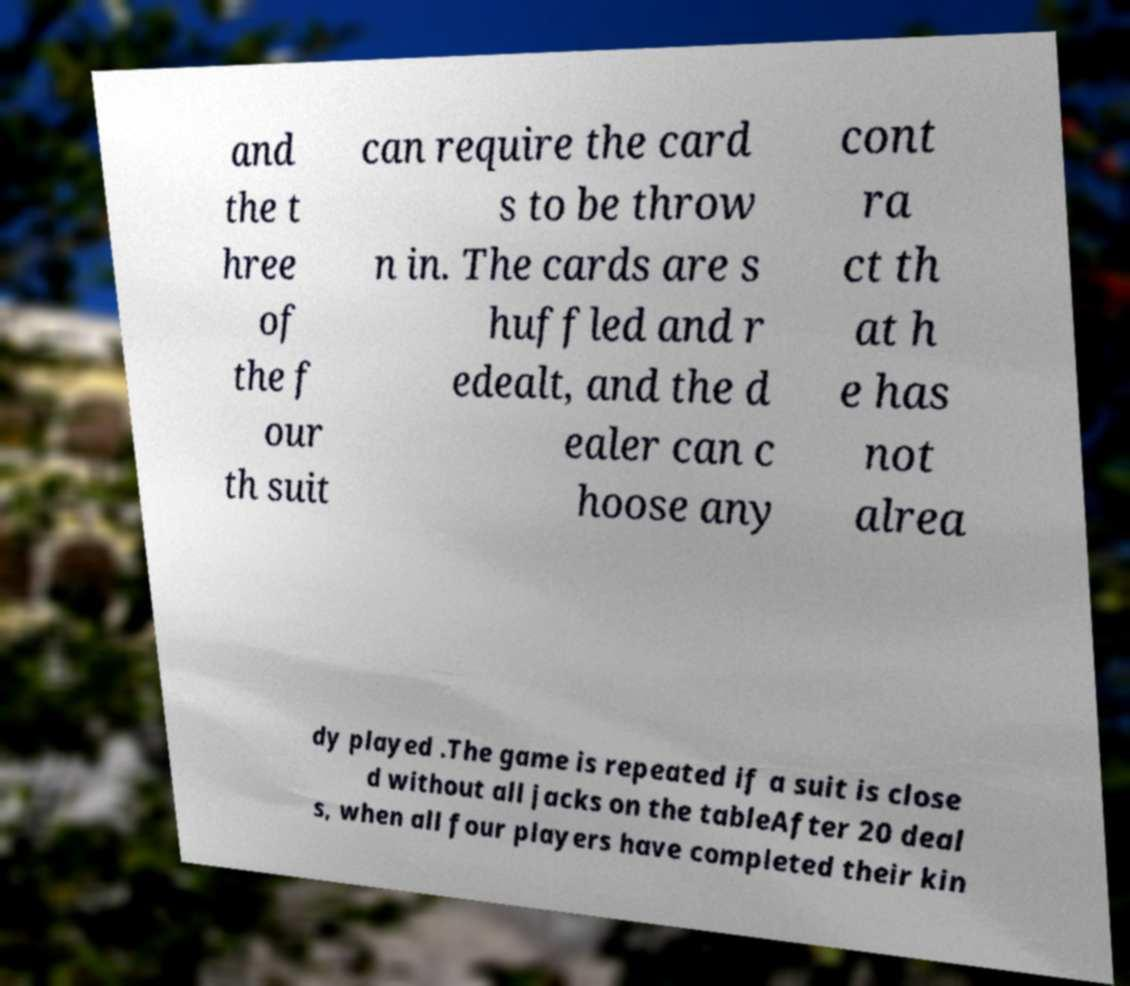Could you extract and type out the text from this image? and the t hree of the f our th suit can require the card s to be throw n in. The cards are s huffled and r edealt, and the d ealer can c hoose any cont ra ct th at h e has not alrea dy played .The game is repeated if a suit is close d without all jacks on the tableAfter 20 deal s, when all four players have completed their kin 